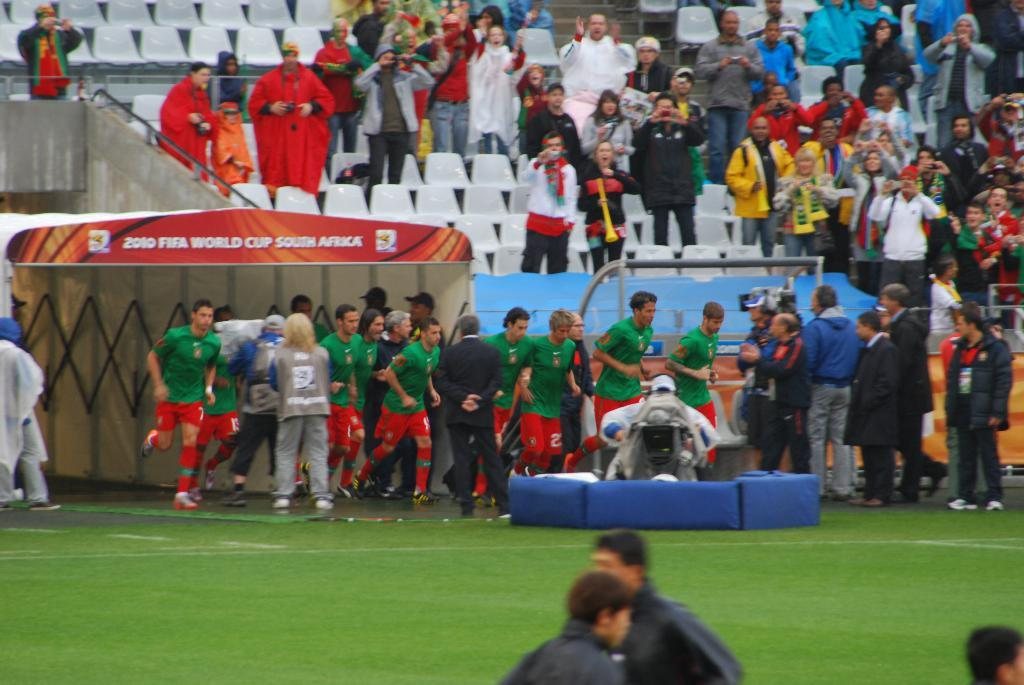Who or what is present in the image? There are people in the image. Where are the people located? The people are in a ground or open area. What furniture can be seen in the image? There are chairs in the image. What are the people at the back of the image doing? People are standing at the back of the image. What type of beam is holding up the patch in the image? There is no beam or patch present in the image. 